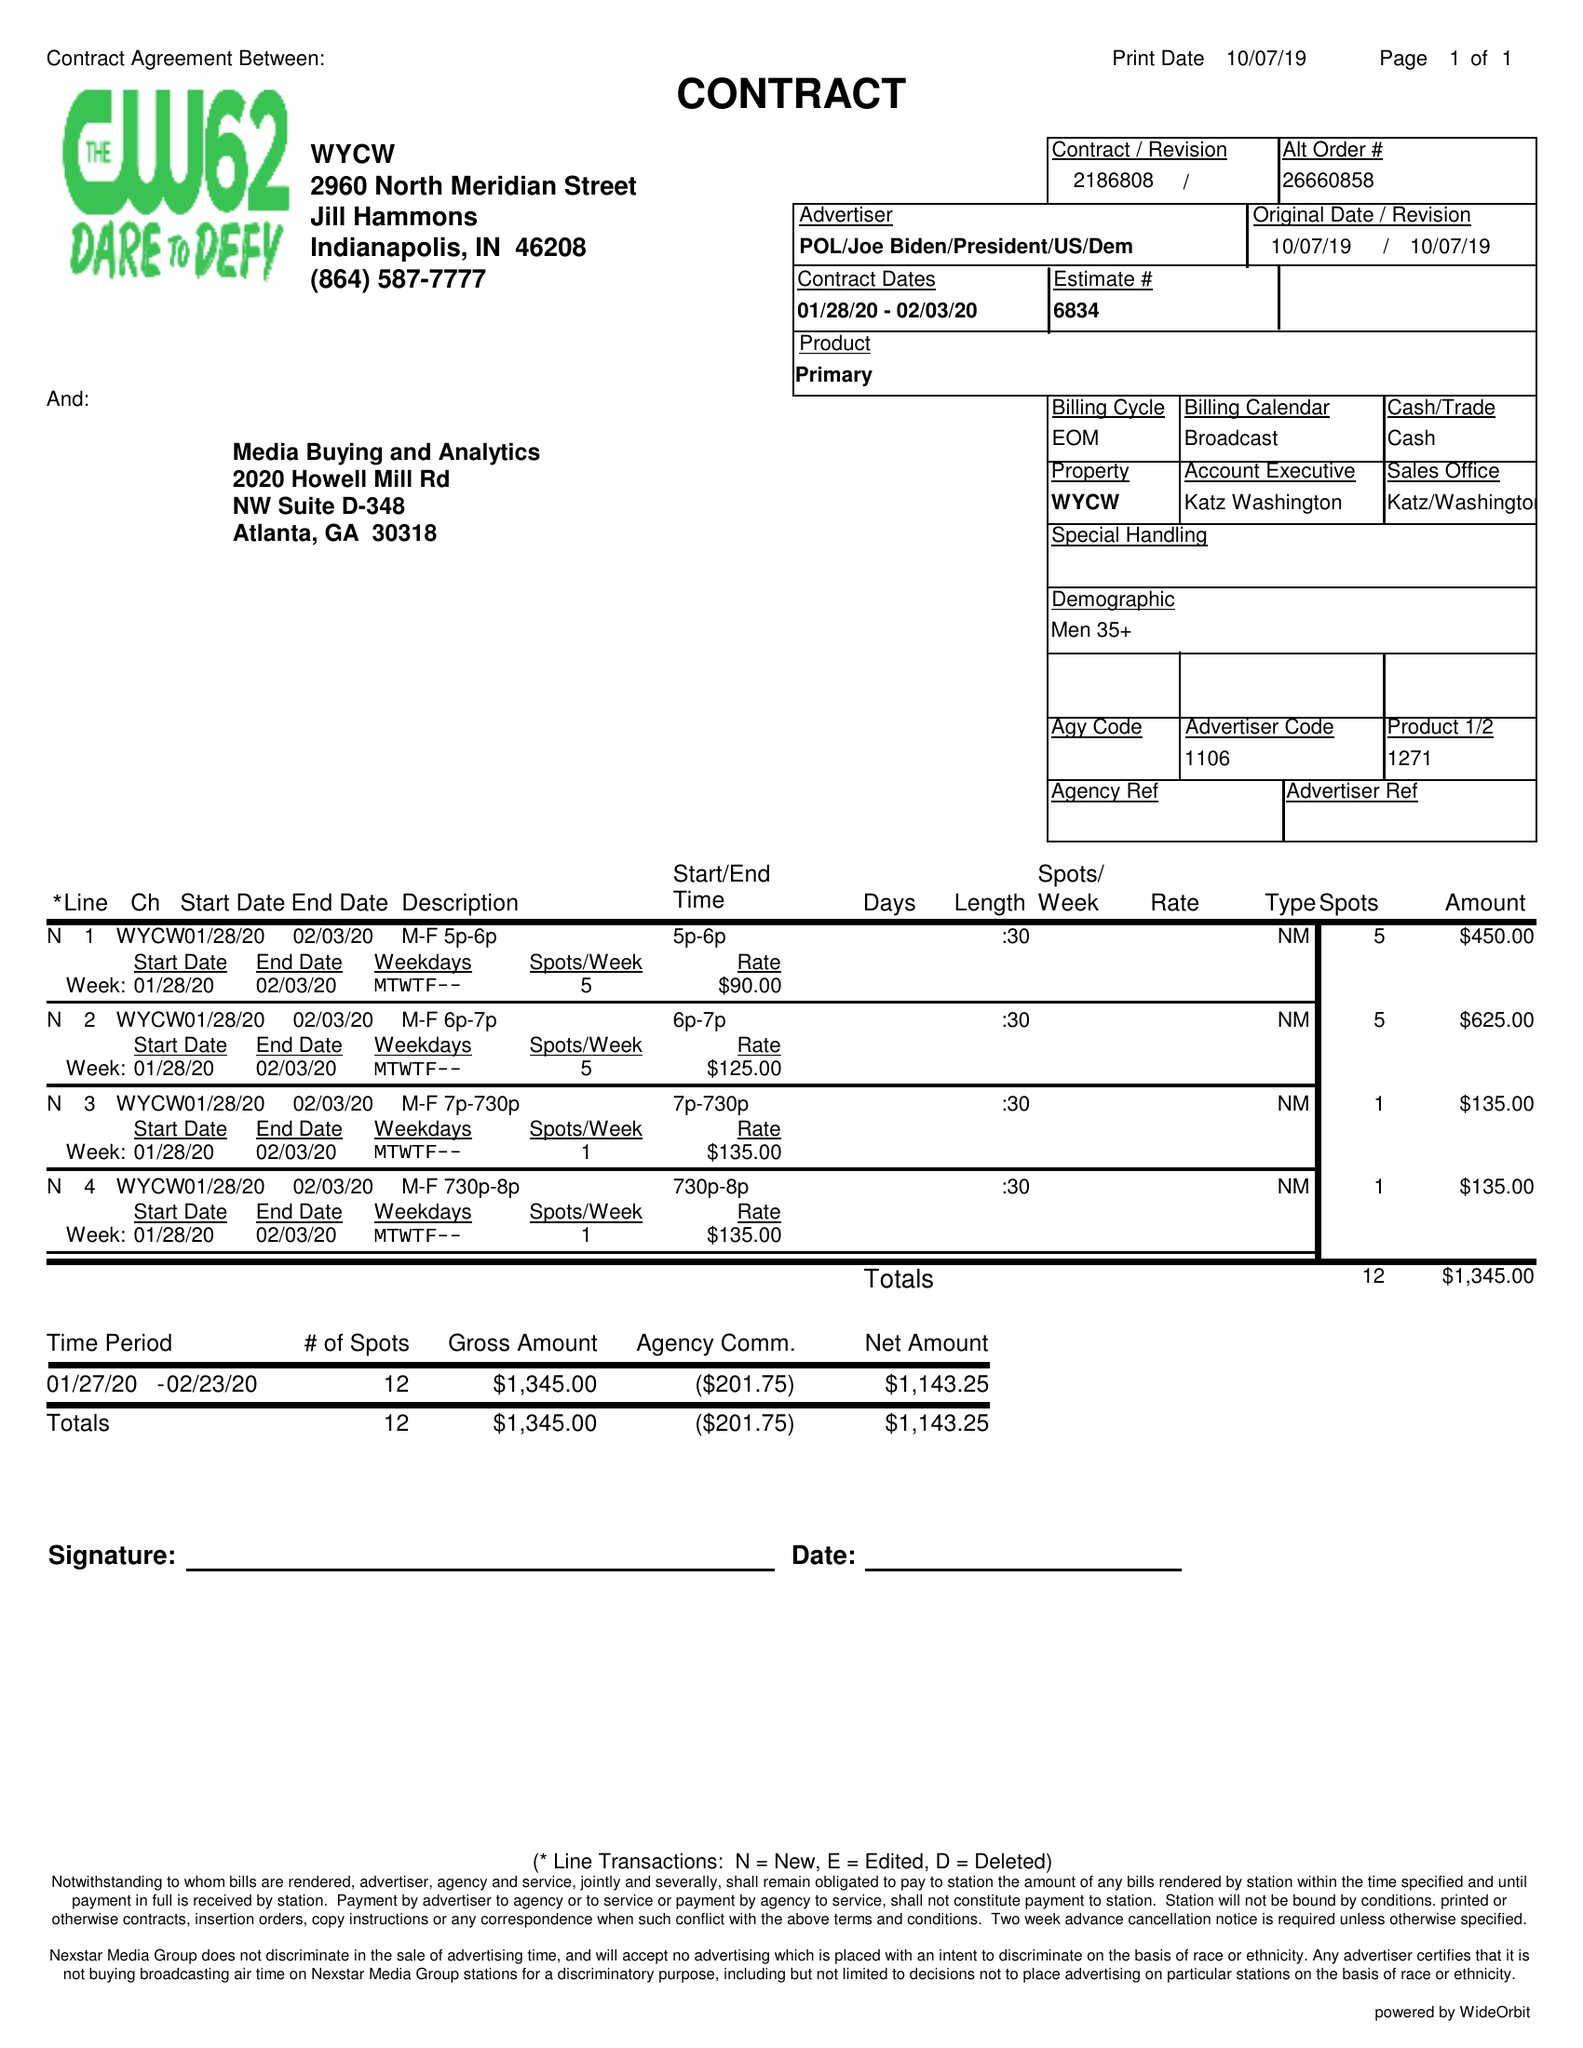What is the value for the contract_num?
Answer the question using a single word or phrase. 2186808 